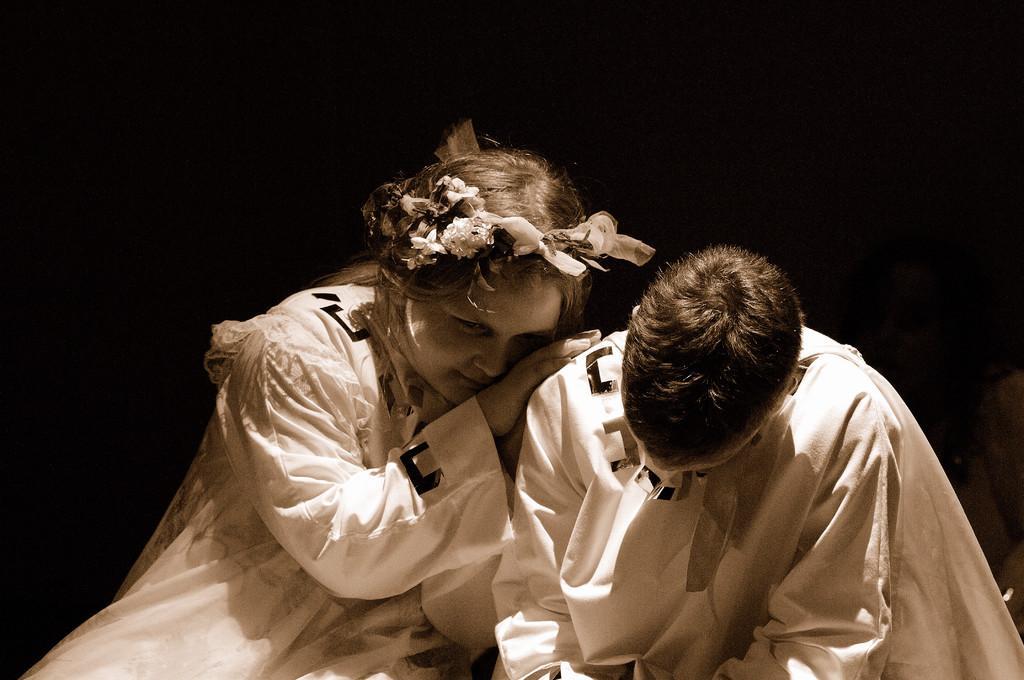How would you summarize this image in a sentence or two? There are two persons. Person on the left is wearing a tiara. In the background it is dark. 